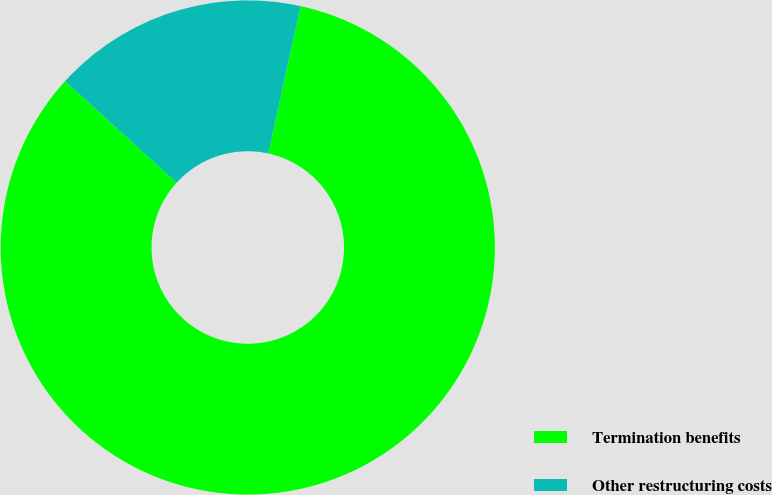<chart> <loc_0><loc_0><loc_500><loc_500><pie_chart><fcel>Termination benefits<fcel>Other restructuring costs<nl><fcel>83.33%<fcel>16.67%<nl></chart> 